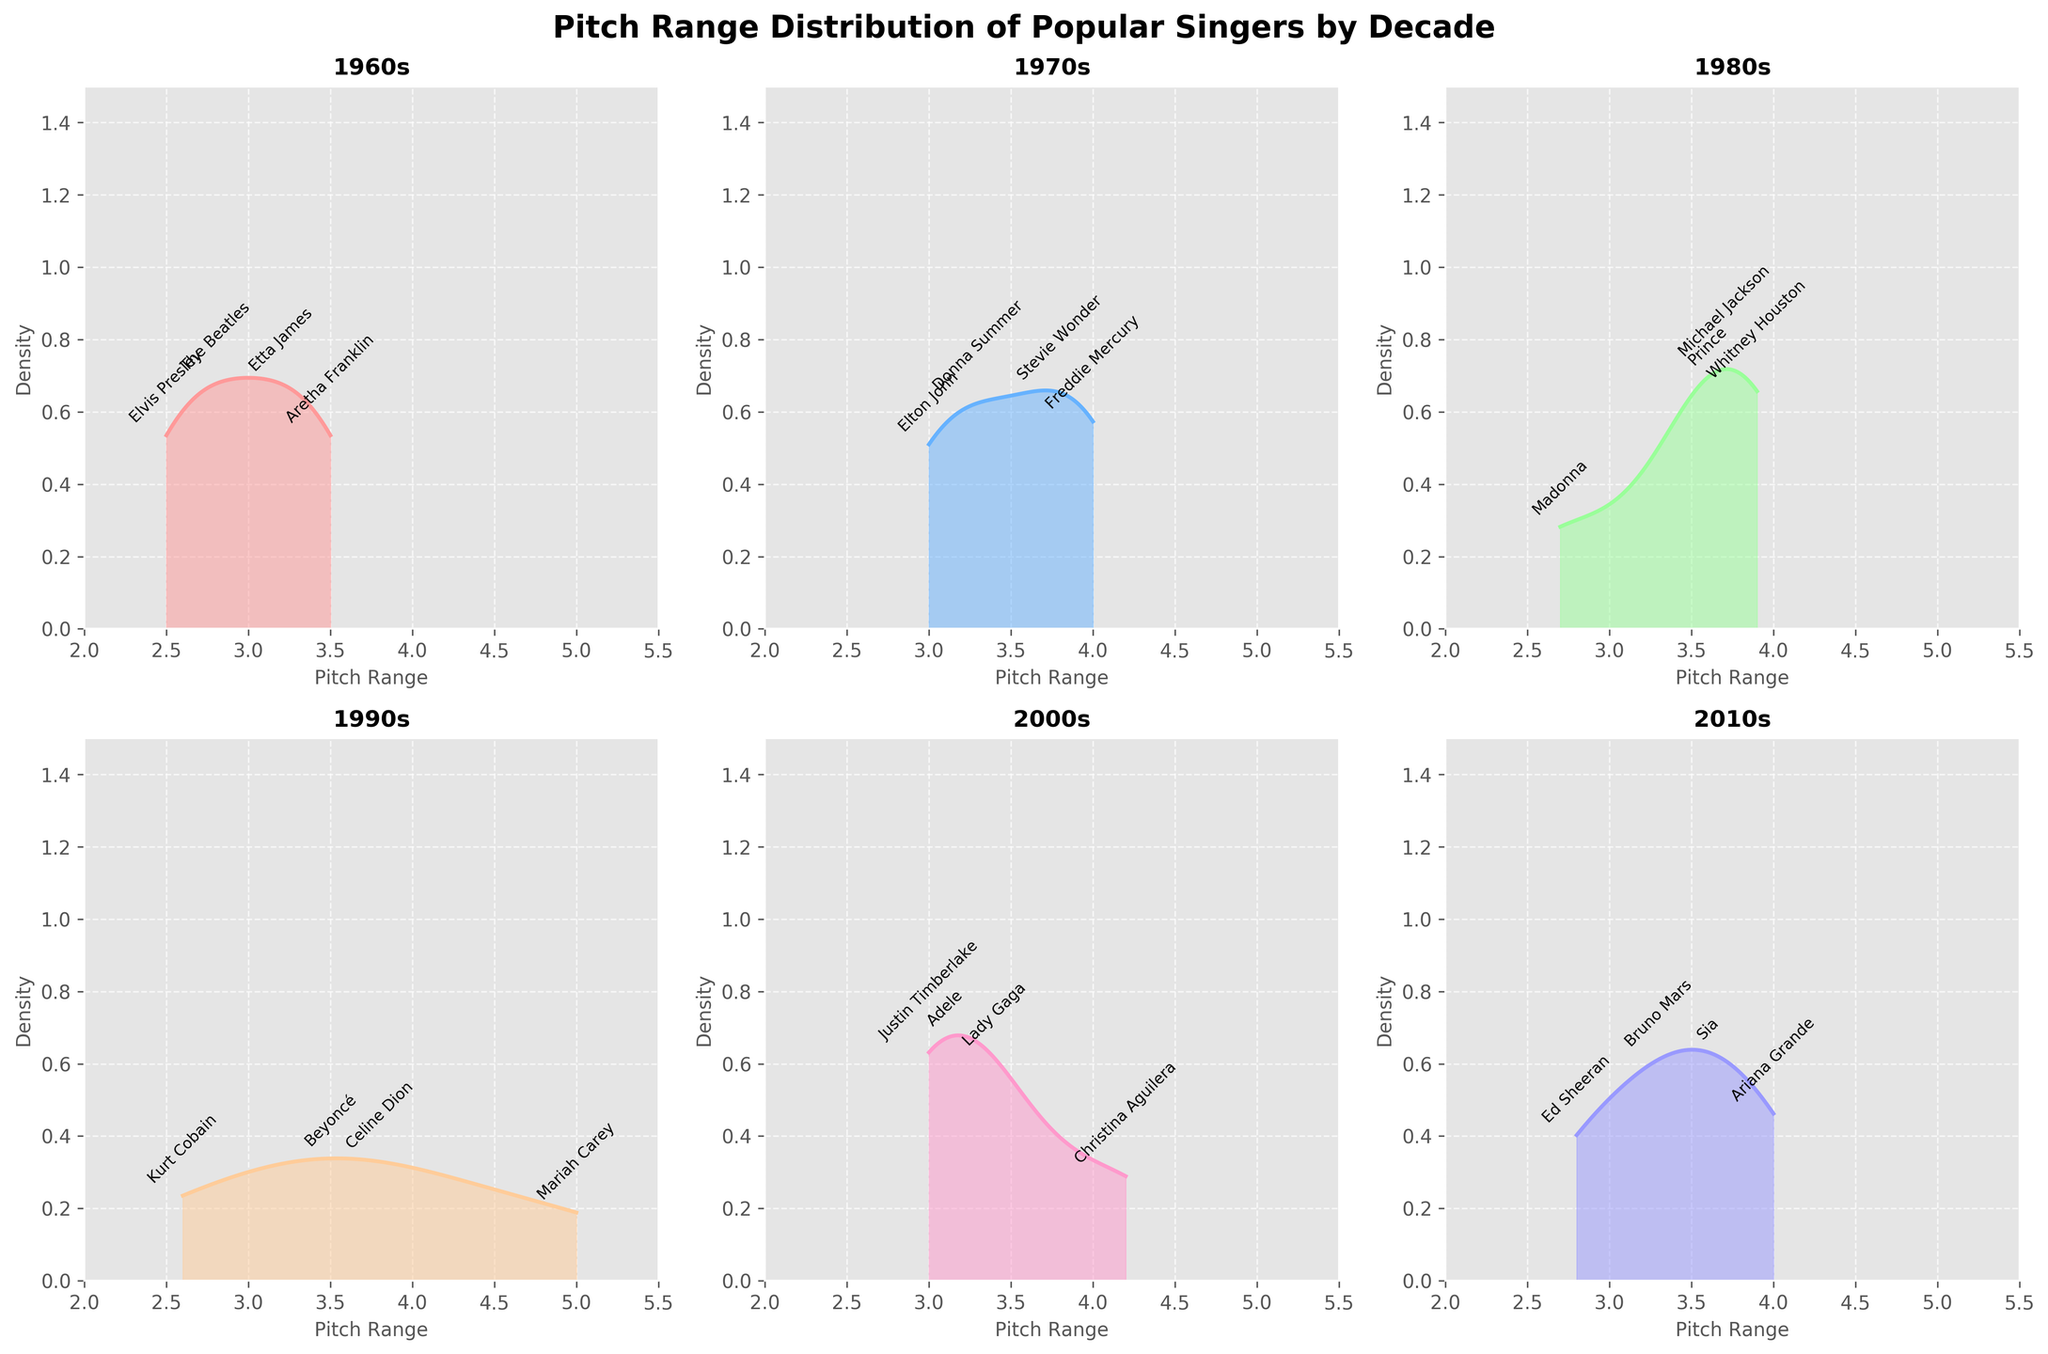What is the title of the figure? The title of the figure is prominently displayed at the top of the plot.
Answer: Pitch Range Distribution of Popular Singers by Decade How many density subplots are there in the figure? By observing the structure, we see there are six subplots arranged in a 2x3 grid layout.
Answer: Six Which decade has the highest pitch range peak density? By examining the kernel density plots, the decade with the highest peak density can be identified. The 1990s have the highest peak density.
Answer: 1990s What is the range of the x-axis in each subplot? The x-axis in each subplot ranges from the minimum value to the maximum value specified in the plot, which is from 2 to 5.5.
Answer: 2 to 5.5 Which singer has the highest pitch range across all decades? By scanning through the annotations for each decade, we find Mariah Carey in the 1990s with a pitch range of 5.0.
Answer: Mariah Carey What is the average pitch range of singers in the 1980s? To find the average, sum the pitch ranges of the 1980s singers and divide by the number of singers: (3.7+3.9+2.7+3.6)/4 = 13.9/4 = 3.475.
Answer: 3.475 Which decade shows the widest distribution of pitch ranges? We observe the spread of the density plots for each decade and find that the 2000s have the widest distribution of pitch ranges.
Answer: 2000s Compare the pitch range sense of peaks for the 1960s and 2010s. Which is higher? By comparing the density peaks for the 1960s and 2010s subplots, it is evident that the 2010s density peaks slightly higher than the 1960s.
Answer: 2010s Is there any overlap in pitch ranges between the 1970s and the 2000s? By observing the density plots for 1970s and 2000s, we can see that there is an overlap in the pitch range values around the 3.0-3.8 range.
Answer: Yes 